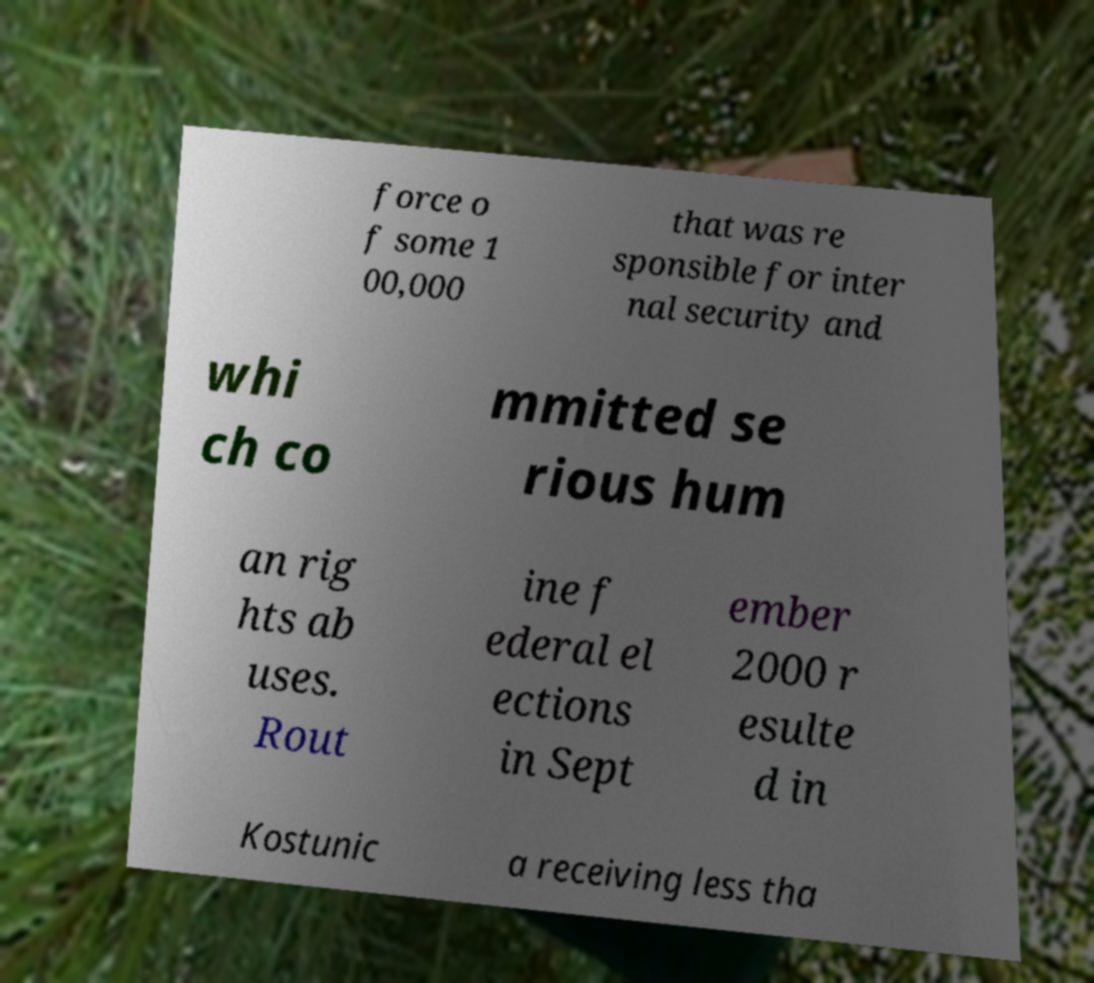Could you assist in decoding the text presented in this image and type it out clearly? force o f some 1 00,000 that was re sponsible for inter nal security and whi ch co mmitted se rious hum an rig hts ab uses. Rout ine f ederal el ections in Sept ember 2000 r esulte d in Kostunic a receiving less tha 